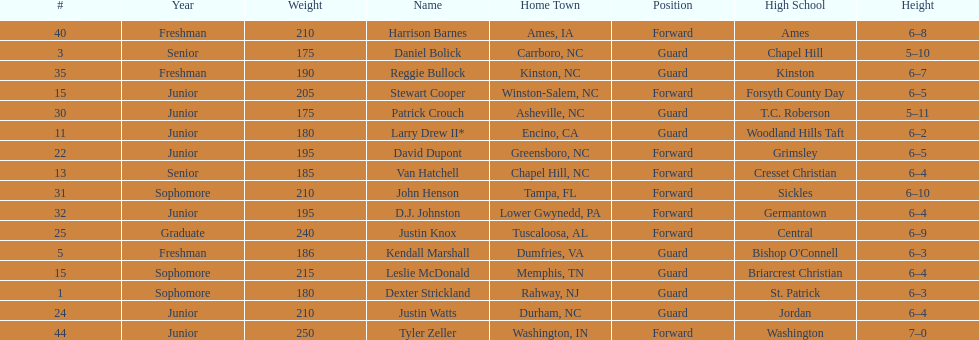Tallest player on the team Tyler Zeller. Can you parse all the data within this table? {'header': ['#', 'Year', 'Weight', 'Name', 'Home Town', 'Position', 'High School', 'Height'], 'rows': [['40', 'Freshman', '210', 'Harrison Barnes', 'Ames, IA', 'Forward', 'Ames', '6–8'], ['3', 'Senior', '175', 'Daniel Bolick', 'Carrboro, NC', 'Guard', 'Chapel Hill', '5–10'], ['35', 'Freshman', '190', 'Reggie Bullock', 'Kinston, NC', 'Guard', 'Kinston', '6–7'], ['15', 'Junior', '205', 'Stewart Cooper', 'Winston-Salem, NC', 'Forward', 'Forsyth County Day', '6–5'], ['30', 'Junior', '175', 'Patrick Crouch', 'Asheville, NC', 'Guard', 'T.C. Roberson', '5–11'], ['11', 'Junior', '180', 'Larry Drew II*', 'Encino, CA', 'Guard', 'Woodland Hills Taft', '6–2'], ['22', 'Junior', '195', 'David Dupont', 'Greensboro, NC', 'Forward', 'Grimsley', '6–5'], ['13', 'Senior', '185', 'Van Hatchell', 'Chapel Hill, NC', 'Forward', 'Cresset Christian', '6–4'], ['31', 'Sophomore', '210', 'John Henson', 'Tampa, FL', 'Forward', 'Sickles', '6–10'], ['32', 'Junior', '195', 'D.J. Johnston', 'Lower Gwynedd, PA', 'Forward', 'Germantown', '6–4'], ['25', 'Graduate', '240', 'Justin Knox', 'Tuscaloosa, AL', 'Forward', 'Central', '6–9'], ['5', 'Freshman', '186', 'Kendall Marshall', 'Dumfries, VA', 'Guard', "Bishop O'Connell", '6–3'], ['15', 'Sophomore', '215', 'Leslie McDonald', 'Memphis, TN', 'Guard', 'Briarcrest Christian', '6–4'], ['1', 'Sophomore', '180', 'Dexter Strickland', 'Rahway, NJ', 'Guard', 'St. Patrick', '6–3'], ['24', 'Junior', '210', 'Justin Watts', 'Durham, NC', 'Guard', 'Jordan', '6–4'], ['44', 'Junior', '250', 'Tyler Zeller', 'Washington, IN', 'Forward', 'Washington', '7–0']]} 